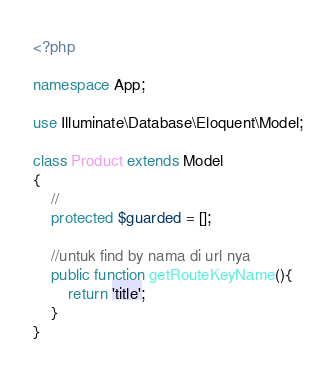<code> <loc_0><loc_0><loc_500><loc_500><_PHP_><?php

namespace App;

use Illuminate\Database\Eloquent\Model;

class Product extends Model
{
    //
    protected $guarded = [];

    //untuk find by nama di url nya
    public function getRouteKeyName(){
        return 'title';
    }
}
</code> 